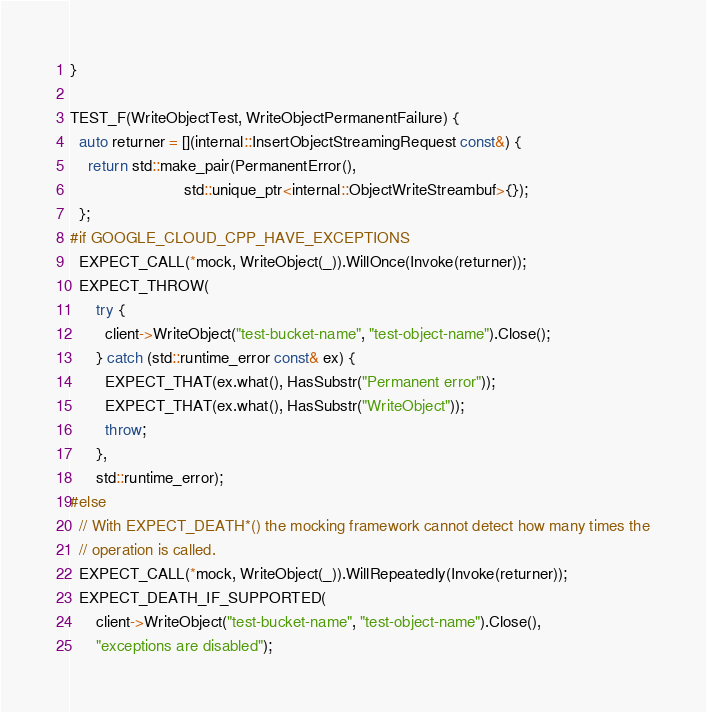Convert code to text. <code><loc_0><loc_0><loc_500><loc_500><_C++_>}

TEST_F(WriteObjectTest, WriteObjectPermanentFailure) {
  auto returner = [](internal::InsertObjectStreamingRequest const&) {
    return std::make_pair(PermanentError(),
                          std::unique_ptr<internal::ObjectWriteStreambuf>{});
  };
#if GOOGLE_CLOUD_CPP_HAVE_EXCEPTIONS
  EXPECT_CALL(*mock, WriteObject(_)).WillOnce(Invoke(returner));
  EXPECT_THROW(
      try {
        client->WriteObject("test-bucket-name", "test-object-name").Close();
      } catch (std::runtime_error const& ex) {
        EXPECT_THAT(ex.what(), HasSubstr("Permanent error"));
        EXPECT_THAT(ex.what(), HasSubstr("WriteObject"));
        throw;
      },
      std::runtime_error);
#else
  // With EXPECT_DEATH*() the mocking framework cannot detect how many times the
  // operation is called.
  EXPECT_CALL(*mock, WriteObject(_)).WillRepeatedly(Invoke(returner));
  EXPECT_DEATH_IF_SUPPORTED(
      client->WriteObject("test-bucket-name", "test-object-name").Close(),
      "exceptions are disabled");</code> 